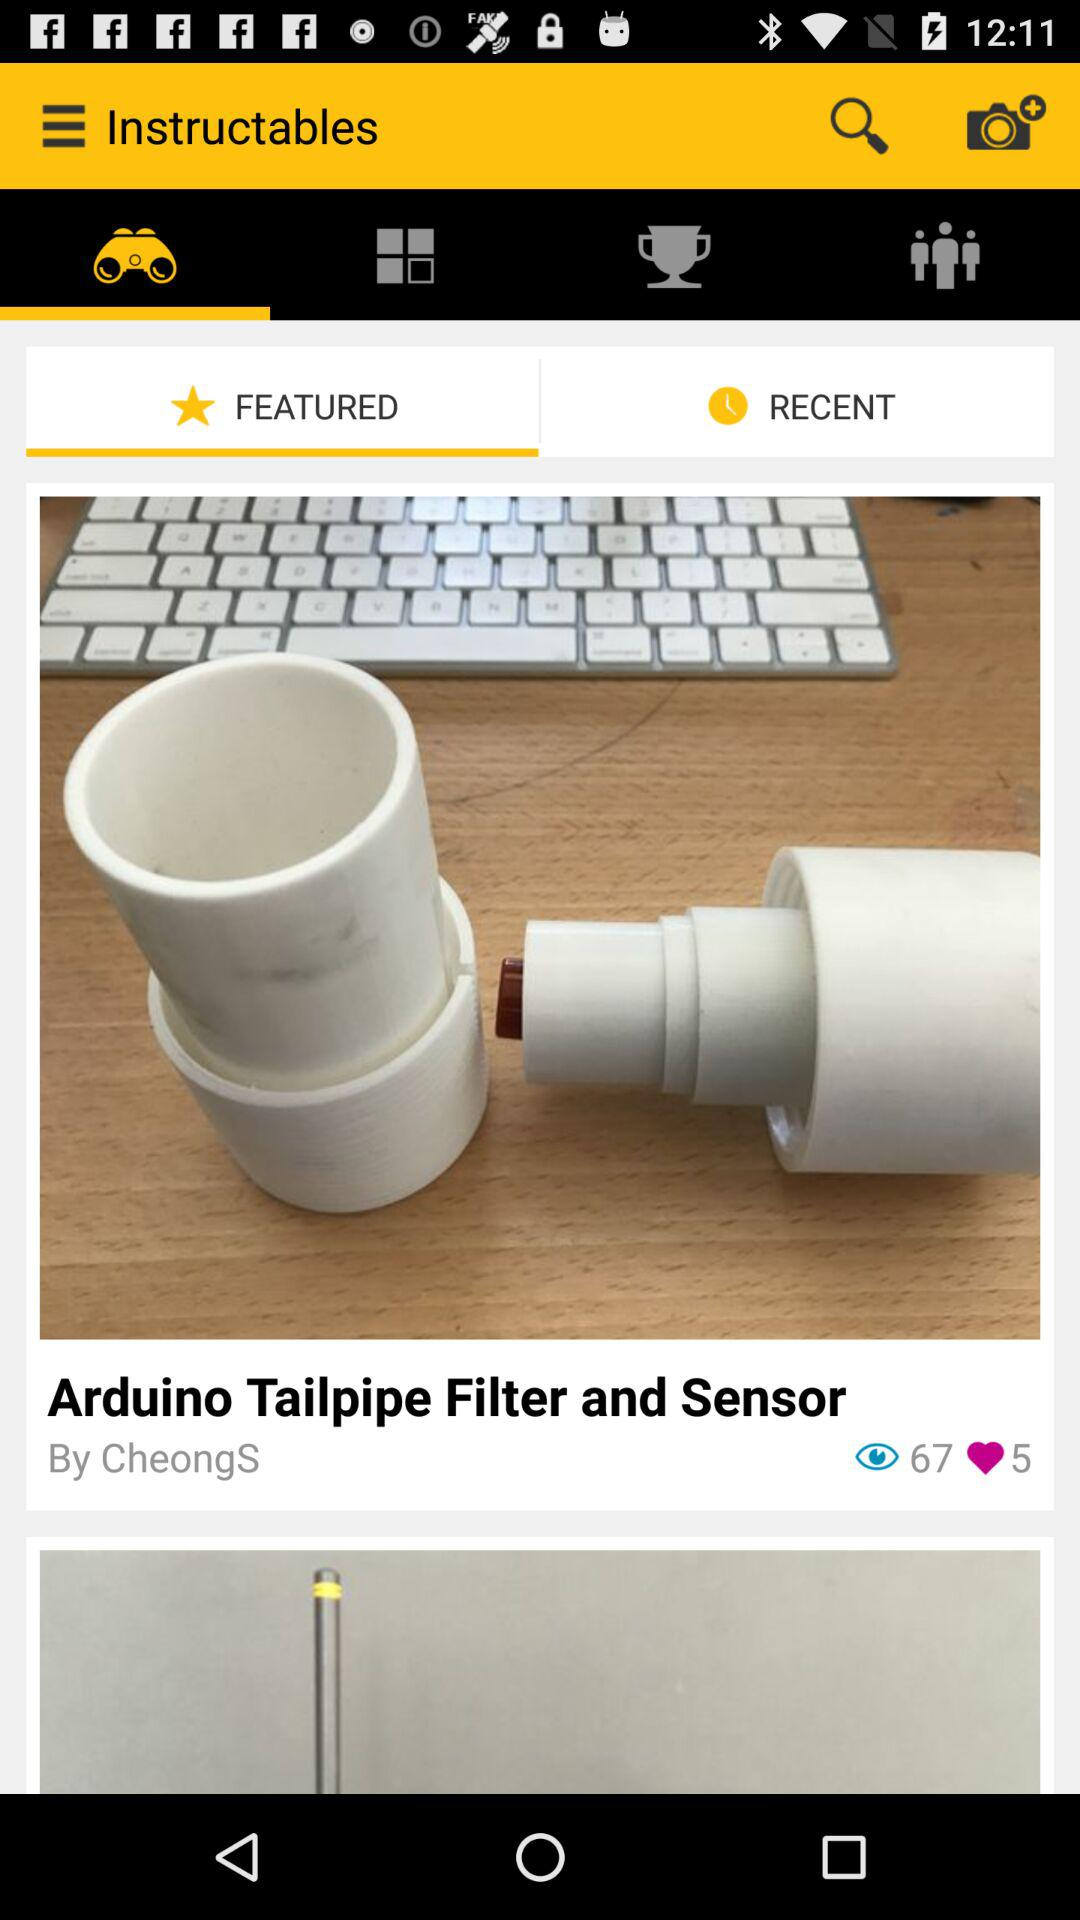Who posted the post "Arduino Tailpipe Filter and Sensor"? The post "Arduino Tailpipe Filter and Sensor" was posted by "CheongS". 